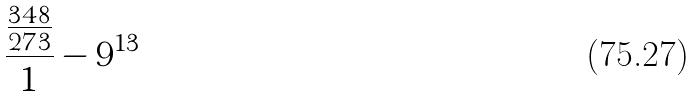<formula> <loc_0><loc_0><loc_500><loc_500>\frac { \frac { 3 4 8 } { 2 7 3 } } { 1 } - 9 ^ { 1 3 }</formula> 